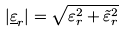Convert formula to latex. <formula><loc_0><loc_0><loc_500><loc_500>| { \underline { \varepsilon } } _ { r } | = { \sqrt { \varepsilon _ { r } ^ { 2 } + { \tilde { \varepsilon } } _ { r } ^ { 2 } } }</formula> 